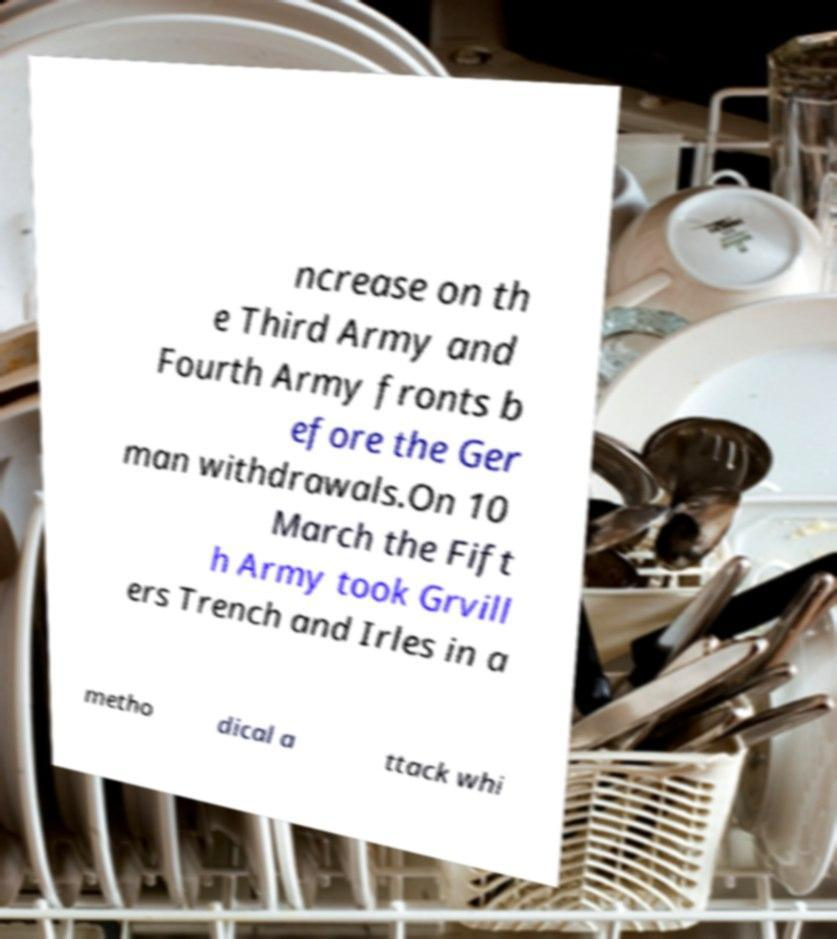There's text embedded in this image that I need extracted. Can you transcribe it verbatim? ncrease on th e Third Army and Fourth Army fronts b efore the Ger man withdrawals.On 10 March the Fift h Army took Grvill ers Trench and Irles in a metho dical a ttack whi 